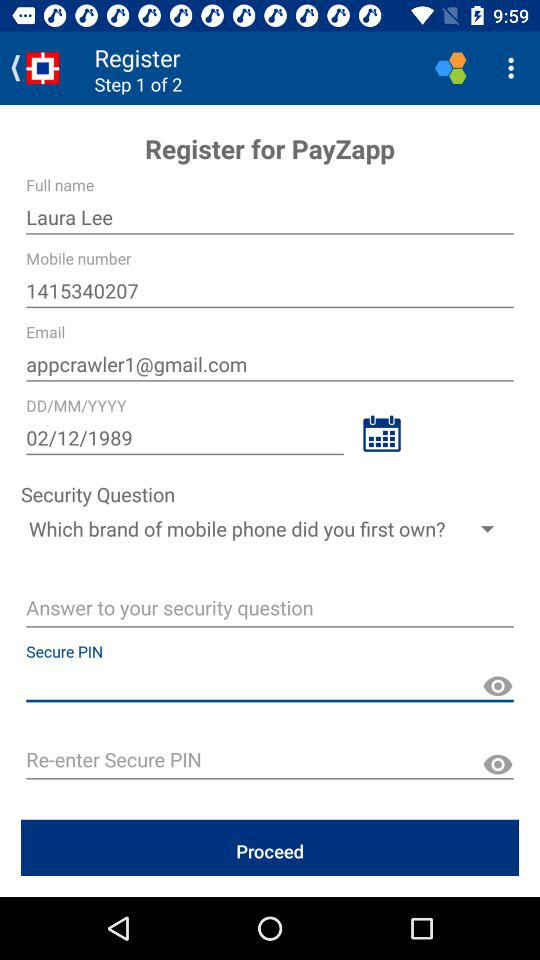What's the Gmail address? The Gmail address is appcrawler1@gmail.com. 